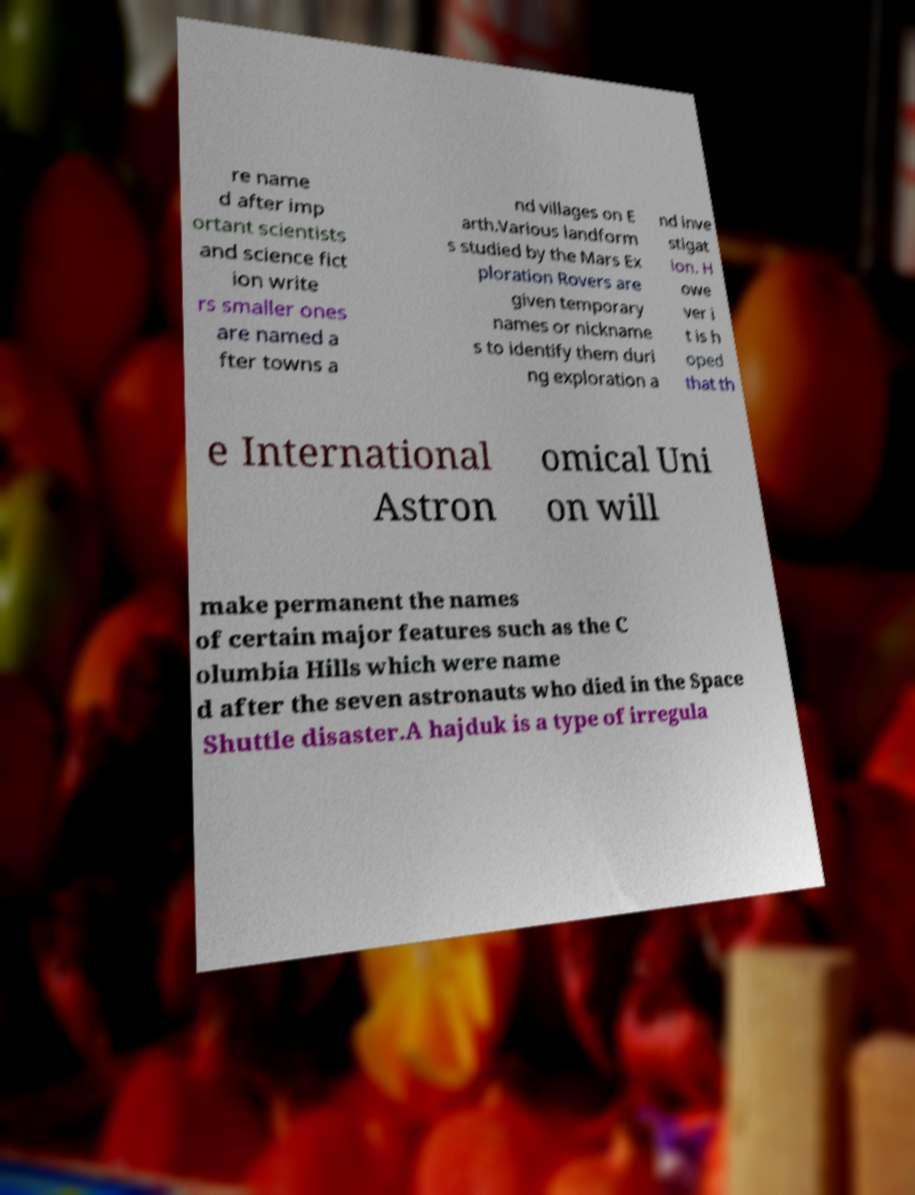There's text embedded in this image that I need extracted. Can you transcribe it verbatim? re name d after imp ortant scientists and science fict ion write rs smaller ones are named a fter towns a nd villages on E arth.Various landform s studied by the Mars Ex ploration Rovers are given temporary names or nickname s to identify them duri ng exploration a nd inve stigat ion. H owe ver i t is h oped that th e International Astron omical Uni on will make permanent the names of certain major features such as the C olumbia Hills which were name d after the seven astronauts who died in the Space Shuttle disaster.A hajduk is a type of irregula 